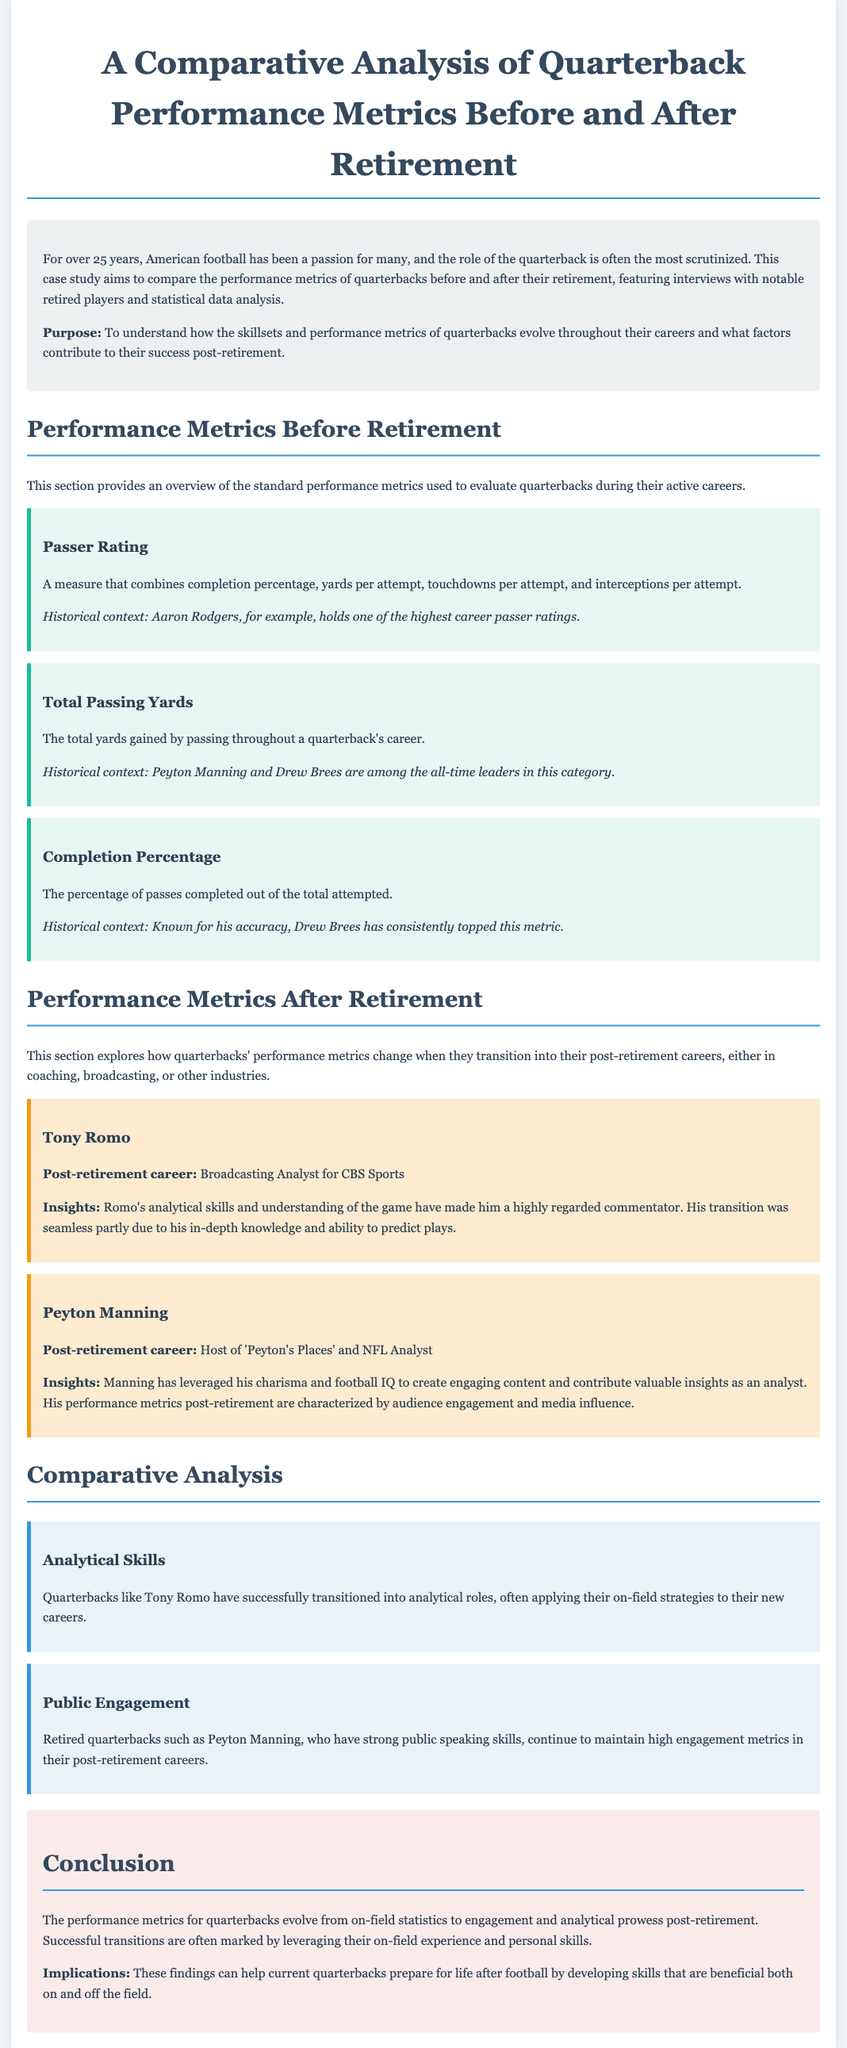What is the purpose of the case study? The purpose is stated to understand how the skillsets and performance metrics of quarterbacks evolve throughout their careers and what factors contribute to their success post-retirement.
Answer: To understand evolution of skillsets and performance metrics What role does Tony Romo have post-retirement? The document mentions that Tony Romo is a Broadcasting Analyst for CBS Sports.
Answer: Broadcasting Analyst for CBS Sports Which quarterback holds one of the highest career passer ratings? Aaron Rodgers is mentioned as holding one of the highest career passer ratings in the historical context.
Answer: Aaron Rodgers What type of transition did Peyton Manning make after retirement? Peyton Manning transitioned into hosting and providing analysis, as stated in the document.
Answer: Host of 'Peyton's Places' and NFL Analyst What is highlighted as a key factor in Romo's successful transition? The document states that Romo's analytical skills and understanding of the game were key factors in his successful transition.
Answer: Analytical skills and understanding of the game What metric is characterized by audience engagement and media influence post-retirement for Manning? The document describes Manning’s post-retirement performance metrics as characterized by audience engagement and media influence.
Answer: Audience engagement and media influence Which metric reflects the percentage of passes completed? Completion Percentage is the metric that reflects this information as stated in the document.
Answer: Completion Percentage What finding discusses retired quarterbacks that apply on-field strategies? The finding about Analytical Skills discusses this aspect as mentioned in the analysis section.
Answer: Analytical Skills 